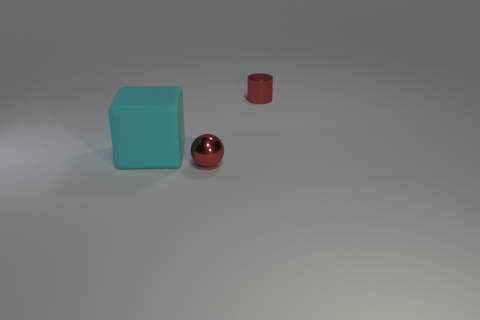Add 3 small red metallic cylinders. How many objects exist? 6 Subtract all cylinders. How many objects are left? 2 Subtract all purple cylinders. How many brown cubes are left? 0 Subtract all small brown rubber cubes. Subtract all cyan objects. How many objects are left? 2 Add 1 cyan objects. How many cyan objects are left? 2 Add 1 small green metallic blocks. How many small green metallic blocks exist? 1 Subtract 0 blue cubes. How many objects are left? 3 Subtract 1 cylinders. How many cylinders are left? 0 Subtract all blue cylinders. Subtract all gray balls. How many cylinders are left? 1 